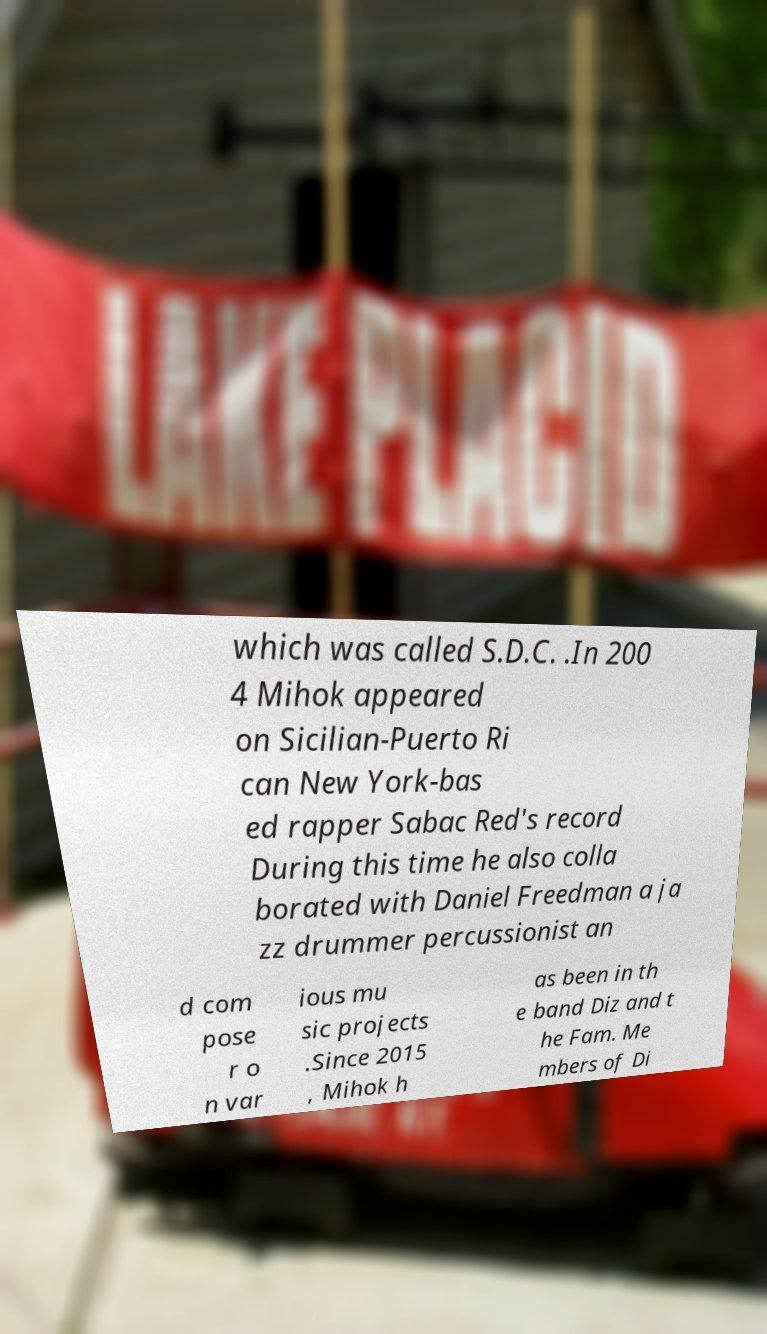I need the written content from this picture converted into text. Can you do that? which was called S.D.C. .In 200 4 Mihok appeared on Sicilian-Puerto Ri can New York-bas ed rapper Sabac Red's record During this time he also colla borated with Daniel Freedman a ja zz drummer percussionist an d com pose r o n var ious mu sic projects .Since 2015 , Mihok h as been in th e band Diz and t he Fam. Me mbers of Di 